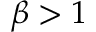<formula> <loc_0><loc_0><loc_500><loc_500>\beta > 1</formula> 